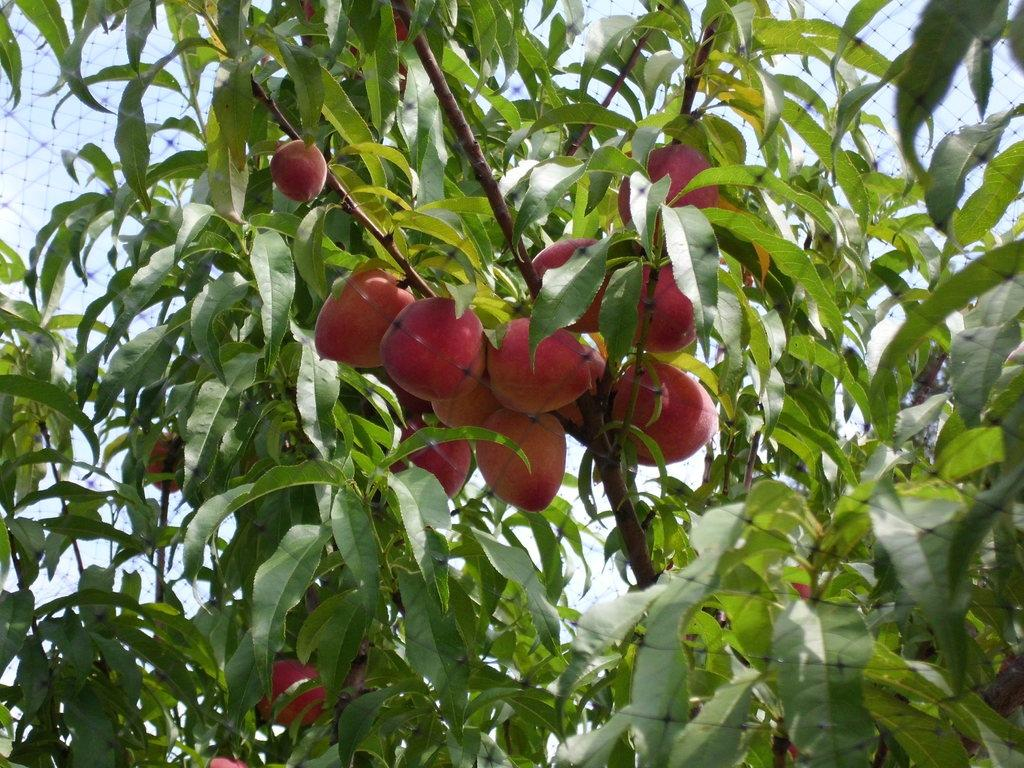What type of plant can be seen in the image? There is a tree in the image. What features of the tree are visible? The tree has branches, leaves, and fruits. What color are the fruits on the tree? The fruits are red in color. What is located in front of the tree? There is a fence in front of the tree. Can you see a fight happening between the tree and the fence in the image? No, there is no fight happening between the tree and the fence in the image. The tree and fence are both stationary objects. 